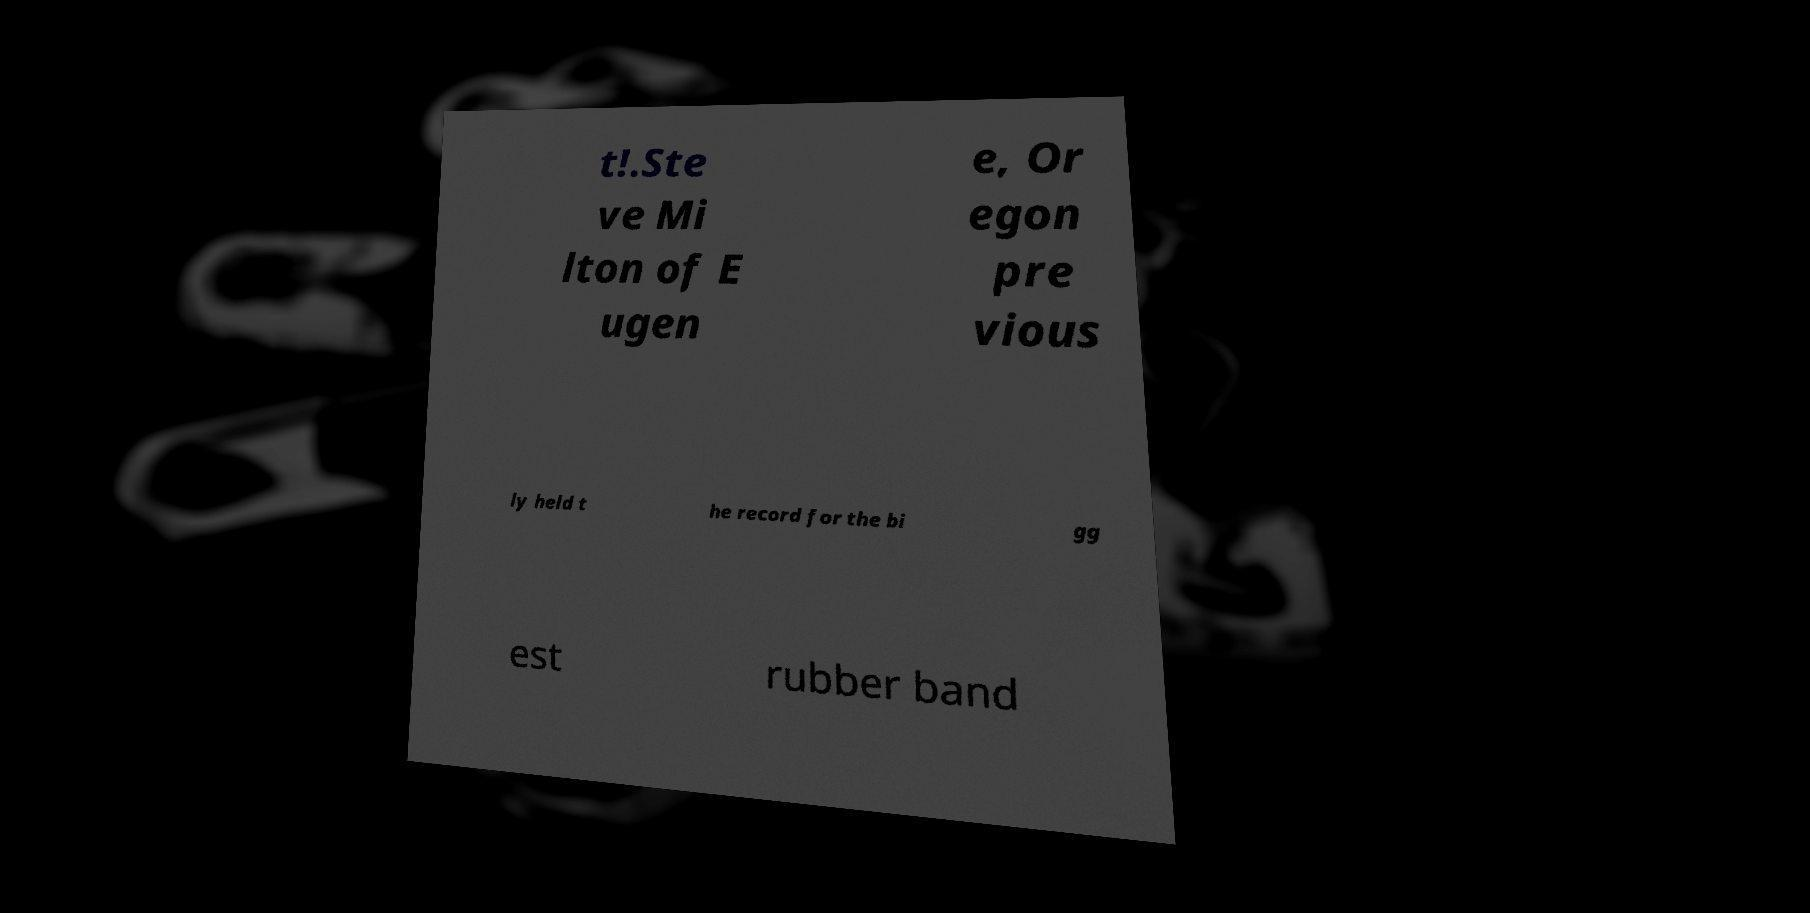Please read and relay the text visible in this image. What does it say? t!.Ste ve Mi lton of E ugen e, Or egon pre vious ly held t he record for the bi gg est rubber band 